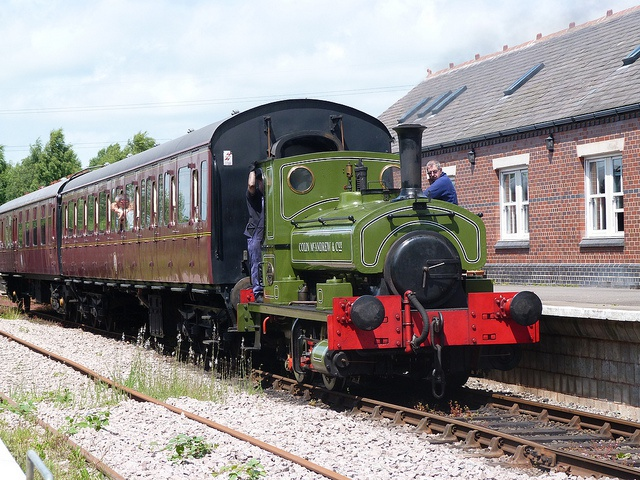Describe the objects in this image and their specific colors. I can see train in lavender, black, gray, darkgreen, and darkgray tones, people in lavender, black, purple, and gray tones, people in lavender, navy, blue, and black tones, people in lavender, lightgray, brown, and darkgray tones, and people in lavender, white, brown, tan, and gray tones in this image. 